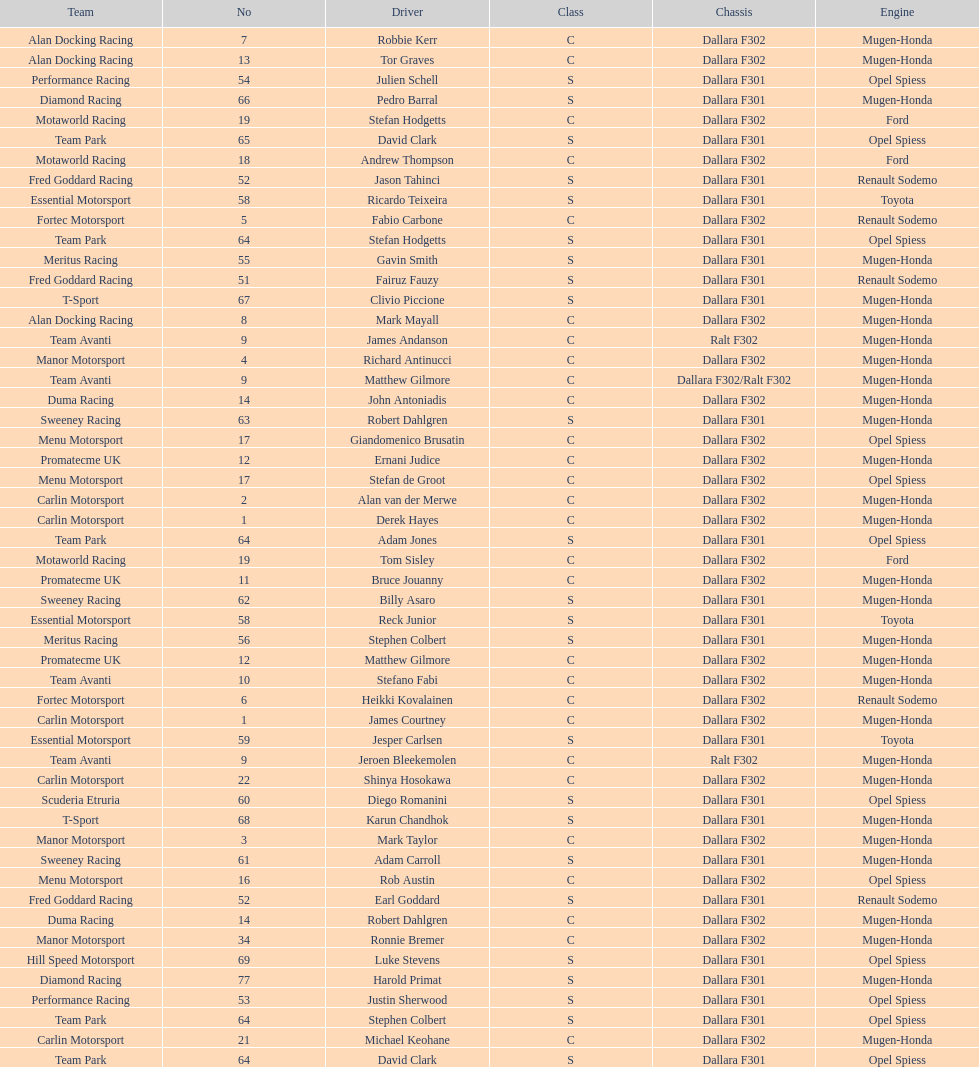What is the average number of teams that had a mugen-honda engine? 24. 